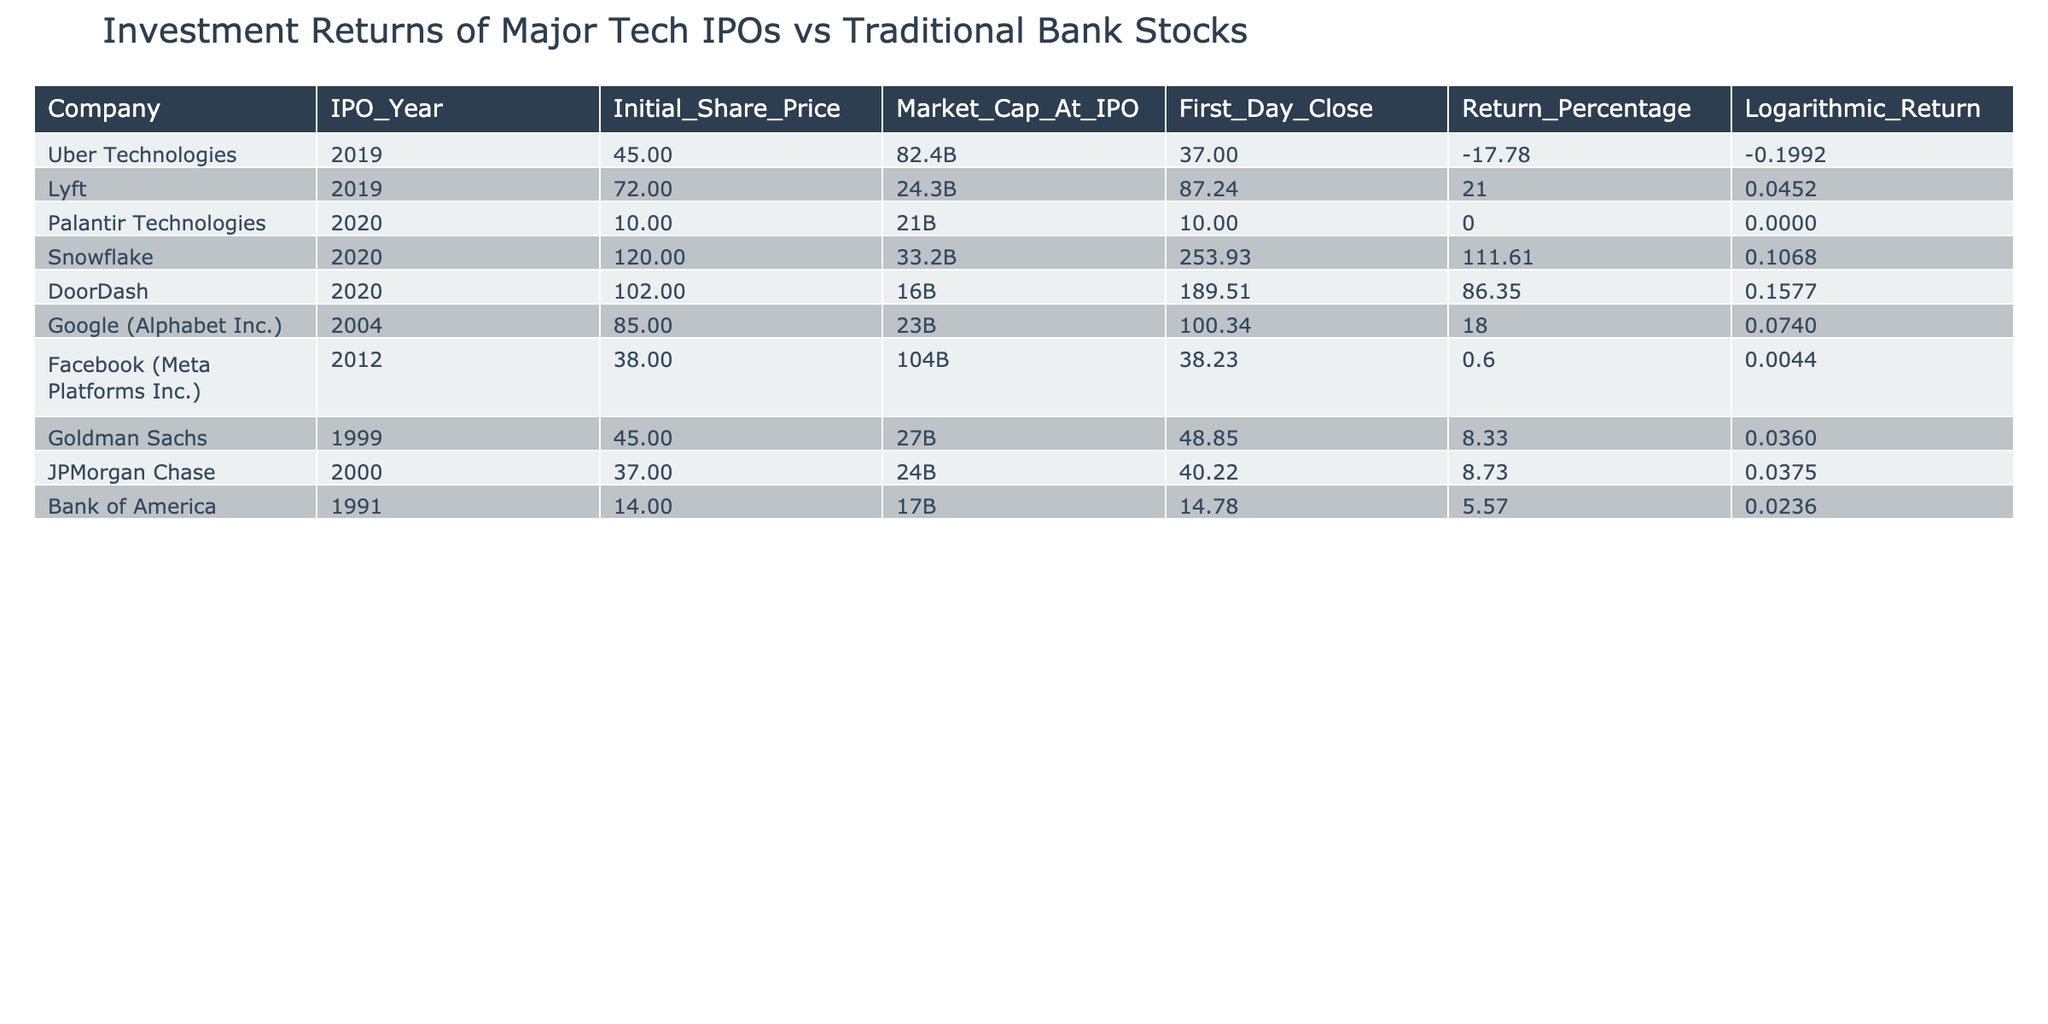What was the initial share price of Snowflake? According to the table, the initial share price of Snowflake is noted in the column labeled "Initial_Share_Price." It is listed as 120.
Answer: 120 Which company had the highest return percentage among the tech IPOs listed? In the column "Return_Percentage," we can identify DoorDash with a return percentage of 86.35, which is higher than any other tech IPO listed.
Answer: DoorDash Did any of the traditional bank stocks have a negative return percentage? By looking at the "Return_Percentage" column for banks, we can see that all the values are positive (Goldman Sachs, JPMorgan Chase, and Bank of America all have positive return percentages), indicating no negative returns.
Answer: No What is the average return percentage for the tech IPOs listed? To find the average for the tech IPOs, I sum the return percentages: (-17.78 + 21.00 + 0.00 + 111.61 + 86.35 + 18.00 + 0.60) = 219.78, and divide by the number of tech IPOs which is 6, resulting in an average of 36.63.
Answer: 36.63 Which company had the highest logarithmic return, and what was its value? The highest value in the "Logarithmic_Return" column is for DoorDash, at 0.1577. This indicates it had the strongest logarithmic return among the listed companies.
Answer: DoorDash, 0.1577 How many companies had a logarithmic return greater than 0? Looking closely at the column "Logarithmic_Return," we see that five companies (Lyft, Snowflake, DoorDash, Google, and Goldman Sachs) have positive values indicating returns greater than 0.
Answer: 5 Did Facebook experience a higher first-day close than its initial share price? We can compare the values in the "First_Day_Close" and "Initial_Share_Price" columns for Facebook. Its first day close is 38.23, which is slightly higher than the initial price of 38.
Answer: Yes What is the difference in market capitalization at IPO between Uber Technologies and Lyft? To find the difference, subtract Lyft's market cap of 24.3B from Uber Technologies' market cap of 82.4B. The calculation gives us 82.4B - 24.3B = 58.1B.
Answer: 58.1B 